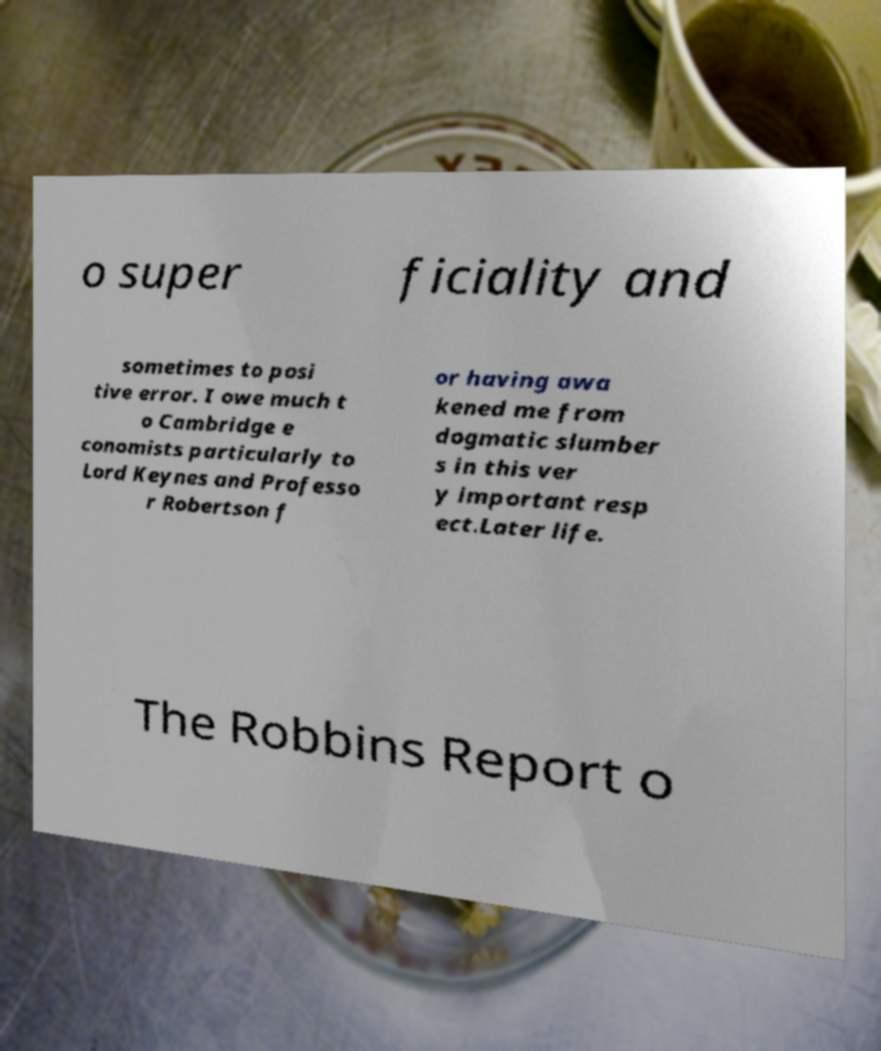I need the written content from this picture converted into text. Can you do that? o super ficiality and sometimes to posi tive error. I owe much t o Cambridge e conomists particularly to Lord Keynes and Professo r Robertson f or having awa kened me from dogmatic slumber s in this ver y important resp ect.Later life. The Robbins Report o 